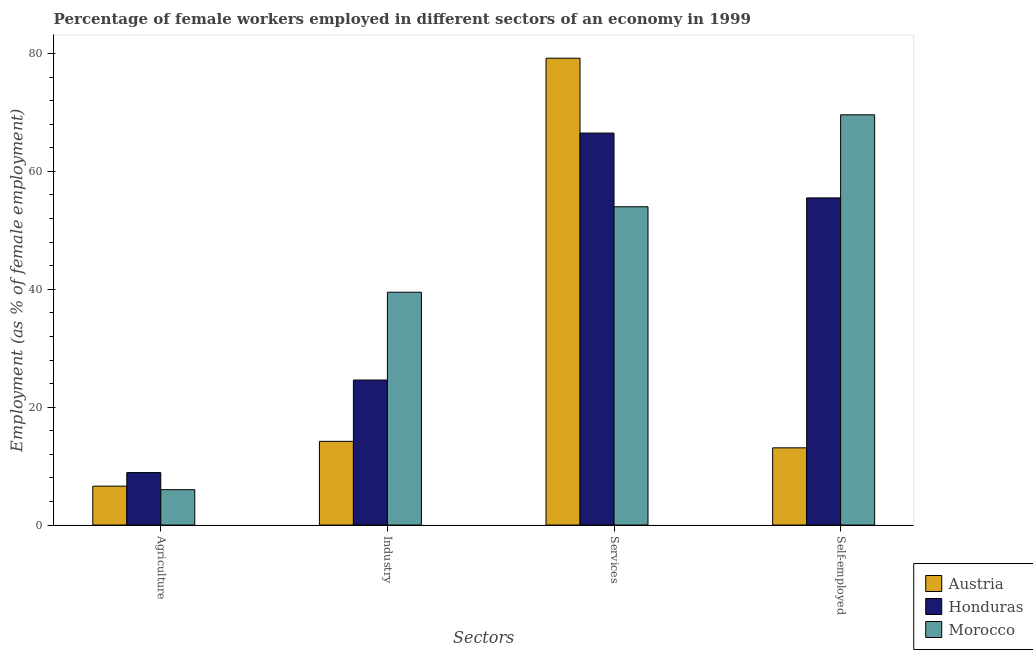How many groups of bars are there?
Your answer should be compact. 4. How many bars are there on the 1st tick from the right?
Ensure brevity in your answer.  3. What is the label of the 4th group of bars from the left?
Make the answer very short. Self-employed. What is the percentage of female workers in agriculture in Honduras?
Offer a very short reply. 8.9. Across all countries, what is the maximum percentage of female workers in agriculture?
Offer a very short reply. 8.9. Across all countries, what is the minimum percentage of female workers in services?
Your answer should be very brief. 54. In which country was the percentage of female workers in agriculture maximum?
Ensure brevity in your answer.  Honduras. In which country was the percentage of self employed female workers minimum?
Offer a terse response. Austria. What is the total percentage of female workers in agriculture in the graph?
Your answer should be compact. 21.5. What is the difference between the percentage of female workers in agriculture in Morocco and that in Austria?
Your answer should be compact. -0.6. What is the difference between the percentage of female workers in services in Morocco and the percentage of female workers in industry in Austria?
Your answer should be compact. 39.8. What is the average percentage of self employed female workers per country?
Ensure brevity in your answer.  46.07. What is the difference between the percentage of female workers in agriculture and percentage of female workers in services in Morocco?
Offer a very short reply. -48. What is the ratio of the percentage of female workers in agriculture in Austria to that in Morocco?
Ensure brevity in your answer.  1.1. Is the percentage of female workers in industry in Austria less than that in Honduras?
Offer a terse response. Yes. Is the difference between the percentage of female workers in industry in Honduras and Morocco greater than the difference between the percentage of female workers in agriculture in Honduras and Morocco?
Your answer should be compact. No. What is the difference between the highest and the second highest percentage of female workers in industry?
Your response must be concise. 14.9. What is the difference between the highest and the lowest percentage of female workers in agriculture?
Ensure brevity in your answer.  2.9. Is the sum of the percentage of female workers in services in Honduras and Austria greater than the maximum percentage of self employed female workers across all countries?
Your response must be concise. Yes. Is it the case that in every country, the sum of the percentage of female workers in services and percentage of self employed female workers is greater than the sum of percentage of female workers in industry and percentage of female workers in agriculture?
Your answer should be very brief. Yes. What does the 3rd bar from the left in Industry represents?
Provide a succinct answer. Morocco. How many bars are there?
Provide a succinct answer. 12. Does the graph contain any zero values?
Provide a short and direct response. No. Where does the legend appear in the graph?
Provide a succinct answer. Bottom right. How are the legend labels stacked?
Your answer should be compact. Vertical. What is the title of the graph?
Provide a short and direct response. Percentage of female workers employed in different sectors of an economy in 1999. Does "Guyana" appear as one of the legend labels in the graph?
Your answer should be compact. No. What is the label or title of the X-axis?
Offer a terse response. Sectors. What is the label or title of the Y-axis?
Provide a succinct answer. Employment (as % of female employment). What is the Employment (as % of female employment) of Austria in Agriculture?
Offer a very short reply. 6.6. What is the Employment (as % of female employment) of Honduras in Agriculture?
Keep it short and to the point. 8.9. What is the Employment (as % of female employment) of Morocco in Agriculture?
Your response must be concise. 6. What is the Employment (as % of female employment) of Austria in Industry?
Ensure brevity in your answer.  14.2. What is the Employment (as % of female employment) of Honduras in Industry?
Your answer should be very brief. 24.6. What is the Employment (as % of female employment) of Morocco in Industry?
Give a very brief answer. 39.5. What is the Employment (as % of female employment) of Austria in Services?
Your answer should be very brief. 79.2. What is the Employment (as % of female employment) in Honduras in Services?
Provide a short and direct response. 66.5. What is the Employment (as % of female employment) in Morocco in Services?
Keep it short and to the point. 54. What is the Employment (as % of female employment) of Austria in Self-employed?
Your answer should be very brief. 13.1. What is the Employment (as % of female employment) in Honduras in Self-employed?
Keep it short and to the point. 55.5. What is the Employment (as % of female employment) of Morocco in Self-employed?
Your answer should be very brief. 69.6. Across all Sectors, what is the maximum Employment (as % of female employment) in Austria?
Your response must be concise. 79.2. Across all Sectors, what is the maximum Employment (as % of female employment) of Honduras?
Your answer should be compact. 66.5. Across all Sectors, what is the maximum Employment (as % of female employment) in Morocco?
Offer a terse response. 69.6. Across all Sectors, what is the minimum Employment (as % of female employment) of Austria?
Offer a very short reply. 6.6. Across all Sectors, what is the minimum Employment (as % of female employment) of Honduras?
Your answer should be very brief. 8.9. Across all Sectors, what is the minimum Employment (as % of female employment) in Morocco?
Provide a succinct answer. 6. What is the total Employment (as % of female employment) in Austria in the graph?
Your answer should be compact. 113.1. What is the total Employment (as % of female employment) of Honduras in the graph?
Your response must be concise. 155.5. What is the total Employment (as % of female employment) of Morocco in the graph?
Offer a terse response. 169.1. What is the difference between the Employment (as % of female employment) of Honduras in Agriculture and that in Industry?
Offer a very short reply. -15.7. What is the difference between the Employment (as % of female employment) of Morocco in Agriculture and that in Industry?
Offer a terse response. -33.5. What is the difference between the Employment (as % of female employment) of Austria in Agriculture and that in Services?
Keep it short and to the point. -72.6. What is the difference between the Employment (as % of female employment) of Honduras in Agriculture and that in Services?
Make the answer very short. -57.6. What is the difference between the Employment (as % of female employment) in Morocco in Agriculture and that in Services?
Give a very brief answer. -48. What is the difference between the Employment (as % of female employment) in Austria in Agriculture and that in Self-employed?
Provide a succinct answer. -6.5. What is the difference between the Employment (as % of female employment) of Honduras in Agriculture and that in Self-employed?
Ensure brevity in your answer.  -46.6. What is the difference between the Employment (as % of female employment) in Morocco in Agriculture and that in Self-employed?
Make the answer very short. -63.6. What is the difference between the Employment (as % of female employment) of Austria in Industry and that in Services?
Your answer should be very brief. -65. What is the difference between the Employment (as % of female employment) in Honduras in Industry and that in Services?
Your response must be concise. -41.9. What is the difference between the Employment (as % of female employment) in Austria in Industry and that in Self-employed?
Keep it short and to the point. 1.1. What is the difference between the Employment (as % of female employment) in Honduras in Industry and that in Self-employed?
Ensure brevity in your answer.  -30.9. What is the difference between the Employment (as % of female employment) of Morocco in Industry and that in Self-employed?
Your answer should be compact. -30.1. What is the difference between the Employment (as % of female employment) of Austria in Services and that in Self-employed?
Keep it short and to the point. 66.1. What is the difference between the Employment (as % of female employment) of Morocco in Services and that in Self-employed?
Keep it short and to the point. -15.6. What is the difference between the Employment (as % of female employment) in Austria in Agriculture and the Employment (as % of female employment) in Morocco in Industry?
Provide a short and direct response. -32.9. What is the difference between the Employment (as % of female employment) of Honduras in Agriculture and the Employment (as % of female employment) of Morocco in Industry?
Offer a very short reply. -30.6. What is the difference between the Employment (as % of female employment) of Austria in Agriculture and the Employment (as % of female employment) of Honduras in Services?
Your response must be concise. -59.9. What is the difference between the Employment (as % of female employment) in Austria in Agriculture and the Employment (as % of female employment) in Morocco in Services?
Your response must be concise. -47.4. What is the difference between the Employment (as % of female employment) in Honduras in Agriculture and the Employment (as % of female employment) in Morocco in Services?
Your response must be concise. -45.1. What is the difference between the Employment (as % of female employment) of Austria in Agriculture and the Employment (as % of female employment) of Honduras in Self-employed?
Offer a very short reply. -48.9. What is the difference between the Employment (as % of female employment) in Austria in Agriculture and the Employment (as % of female employment) in Morocco in Self-employed?
Make the answer very short. -63. What is the difference between the Employment (as % of female employment) of Honduras in Agriculture and the Employment (as % of female employment) of Morocco in Self-employed?
Give a very brief answer. -60.7. What is the difference between the Employment (as % of female employment) in Austria in Industry and the Employment (as % of female employment) in Honduras in Services?
Provide a short and direct response. -52.3. What is the difference between the Employment (as % of female employment) in Austria in Industry and the Employment (as % of female employment) in Morocco in Services?
Offer a terse response. -39.8. What is the difference between the Employment (as % of female employment) in Honduras in Industry and the Employment (as % of female employment) in Morocco in Services?
Keep it short and to the point. -29.4. What is the difference between the Employment (as % of female employment) in Austria in Industry and the Employment (as % of female employment) in Honduras in Self-employed?
Your answer should be compact. -41.3. What is the difference between the Employment (as % of female employment) in Austria in Industry and the Employment (as % of female employment) in Morocco in Self-employed?
Your response must be concise. -55.4. What is the difference between the Employment (as % of female employment) of Honduras in Industry and the Employment (as % of female employment) of Morocco in Self-employed?
Your answer should be compact. -45. What is the difference between the Employment (as % of female employment) in Austria in Services and the Employment (as % of female employment) in Honduras in Self-employed?
Your answer should be very brief. 23.7. What is the difference between the Employment (as % of female employment) of Austria in Services and the Employment (as % of female employment) of Morocco in Self-employed?
Your answer should be compact. 9.6. What is the average Employment (as % of female employment) of Austria per Sectors?
Provide a succinct answer. 28.27. What is the average Employment (as % of female employment) in Honduras per Sectors?
Provide a succinct answer. 38.88. What is the average Employment (as % of female employment) of Morocco per Sectors?
Keep it short and to the point. 42.27. What is the difference between the Employment (as % of female employment) of Austria and Employment (as % of female employment) of Morocco in Agriculture?
Your answer should be very brief. 0.6. What is the difference between the Employment (as % of female employment) of Austria and Employment (as % of female employment) of Morocco in Industry?
Give a very brief answer. -25.3. What is the difference between the Employment (as % of female employment) in Honduras and Employment (as % of female employment) in Morocco in Industry?
Provide a succinct answer. -14.9. What is the difference between the Employment (as % of female employment) of Austria and Employment (as % of female employment) of Honduras in Services?
Your response must be concise. 12.7. What is the difference between the Employment (as % of female employment) in Austria and Employment (as % of female employment) in Morocco in Services?
Your response must be concise. 25.2. What is the difference between the Employment (as % of female employment) in Austria and Employment (as % of female employment) in Honduras in Self-employed?
Offer a terse response. -42.4. What is the difference between the Employment (as % of female employment) in Austria and Employment (as % of female employment) in Morocco in Self-employed?
Offer a very short reply. -56.5. What is the difference between the Employment (as % of female employment) in Honduras and Employment (as % of female employment) in Morocco in Self-employed?
Your response must be concise. -14.1. What is the ratio of the Employment (as % of female employment) in Austria in Agriculture to that in Industry?
Your answer should be very brief. 0.46. What is the ratio of the Employment (as % of female employment) in Honduras in Agriculture to that in Industry?
Your answer should be compact. 0.36. What is the ratio of the Employment (as % of female employment) in Morocco in Agriculture to that in Industry?
Give a very brief answer. 0.15. What is the ratio of the Employment (as % of female employment) in Austria in Agriculture to that in Services?
Offer a terse response. 0.08. What is the ratio of the Employment (as % of female employment) of Honduras in Agriculture to that in Services?
Offer a terse response. 0.13. What is the ratio of the Employment (as % of female employment) of Austria in Agriculture to that in Self-employed?
Provide a short and direct response. 0.5. What is the ratio of the Employment (as % of female employment) in Honduras in Agriculture to that in Self-employed?
Make the answer very short. 0.16. What is the ratio of the Employment (as % of female employment) in Morocco in Agriculture to that in Self-employed?
Provide a succinct answer. 0.09. What is the ratio of the Employment (as % of female employment) in Austria in Industry to that in Services?
Your answer should be compact. 0.18. What is the ratio of the Employment (as % of female employment) of Honduras in Industry to that in Services?
Keep it short and to the point. 0.37. What is the ratio of the Employment (as % of female employment) of Morocco in Industry to that in Services?
Your answer should be compact. 0.73. What is the ratio of the Employment (as % of female employment) in Austria in Industry to that in Self-employed?
Make the answer very short. 1.08. What is the ratio of the Employment (as % of female employment) of Honduras in Industry to that in Self-employed?
Ensure brevity in your answer.  0.44. What is the ratio of the Employment (as % of female employment) in Morocco in Industry to that in Self-employed?
Your response must be concise. 0.57. What is the ratio of the Employment (as % of female employment) of Austria in Services to that in Self-employed?
Your answer should be compact. 6.05. What is the ratio of the Employment (as % of female employment) in Honduras in Services to that in Self-employed?
Your response must be concise. 1.2. What is the ratio of the Employment (as % of female employment) of Morocco in Services to that in Self-employed?
Give a very brief answer. 0.78. What is the difference between the highest and the second highest Employment (as % of female employment) in Austria?
Your answer should be very brief. 65. What is the difference between the highest and the second highest Employment (as % of female employment) in Honduras?
Provide a succinct answer. 11. What is the difference between the highest and the lowest Employment (as % of female employment) in Austria?
Your answer should be very brief. 72.6. What is the difference between the highest and the lowest Employment (as % of female employment) in Honduras?
Your response must be concise. 57.6. What is the difference between the highest and the lowest Employment (as % of female employment) of Morocco?
Provide a succinct answer. 63.6. 